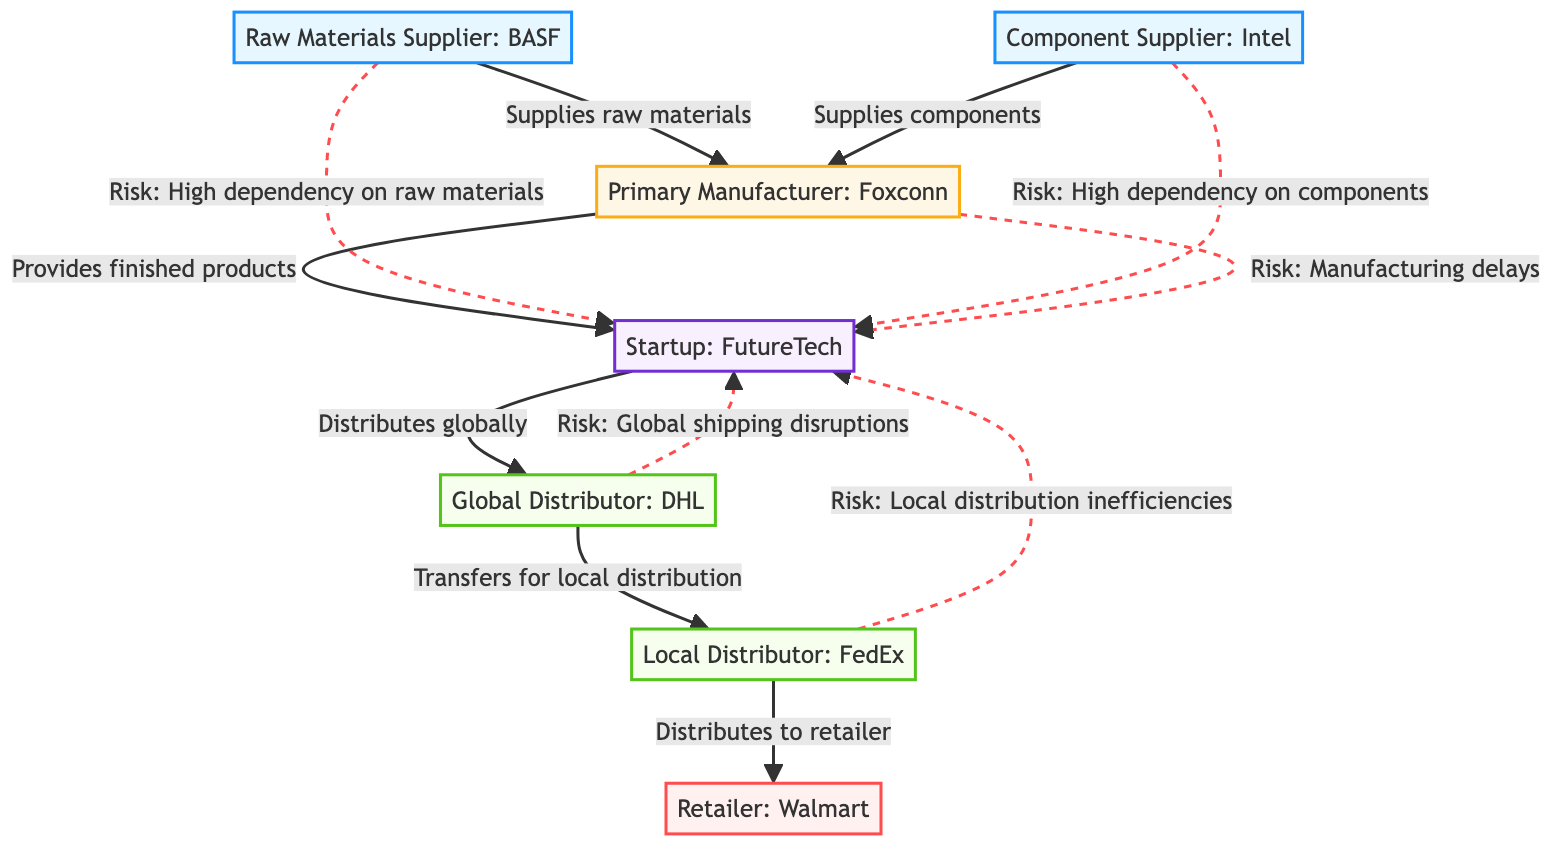What's the total number of nodes in the diagram? The diagram contains several named entities: Suppliers (2), Manufacturer (1), Distributors (2), Customer (1), and the Startup (1). Adding these gives a total of 7 nodes.
Answer: 7 What is the relationship between Supplier1 and Manufacturer1? Supplier1, identified as "Raw Materials Supplier: BASF," has a direct relationship with Manufacturer1 stating that it "Supplies raw materials."
Answer: Supplies raw materials Who distributes globally for the Startup? The Startup has a direct connection to Distributor1, which is labeled "Global Distributor: DHL." This indicates that Distributor1 is responsible for global distribution.
Answer: Global Distributor: DHL How many risks are associated with Supplier2? The diagram shows a specific connection from Supplier2 to the Startup that states "Risk: High dependency on components." This shows one identified risk associated with Supplier2.
Answer: 1 What type of distributor is FedEx? In the diagram, "FedEx" is labeled as "Local Distributor," indicating its specific role in the distribution network.
Answer: Local Distributor Which entity provides finished products to the Startup? The arrow from Manufacturer1 points to the Startup with a relationship described as "Provides finished products." This shows that Manufacturer1 is responsible for this supply chain step.
Answer: Manufacturer: Foxconn What risks are associated with Distributor1? Distributor1 has a risk relationship with the Startup stating "Risk: Global shipping disruptions." This highlights a potential issue in the global distribution process.
Answer: Risk: Global shipping disruptions Which supplier has a high dependency risk to the Startup? The diagram indicates that both Supplier1 and Supplier2 have high dependency risks to the Startup. However, the question specifically highlights any one of them. One instance states "Risk: High dependency on raw materials."
Answer: Risk: High dependency on raw materials 